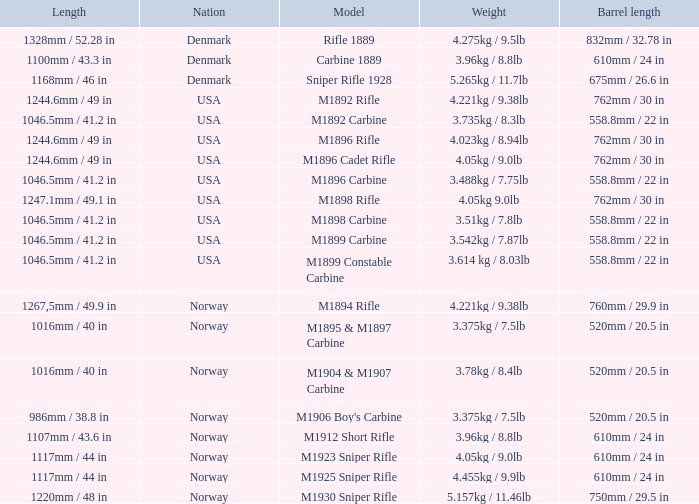What is Nation, when Model is M1895 & M1897 Carbine? Norway. 